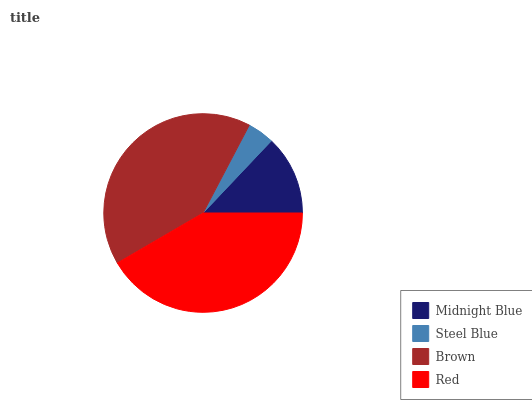Is Steel Blue the minimum?
Answer yes or no. Yes. Is Red the maximum?
Answer yes or no. Yes. Is Brown the minimum?
Answer yes or no. No. Is Brown the maximum?
Answer yes or no. No. Is Brown greater than Steel Blue?
Answer yes or no. Yes. Is Steel Blue less than Brown?
Answer yes or no. Yes. Is Steel Blue greater than Brown?
Answer yes or no. No. Is Brown less than Steel Blue?
Answer yes or no. No. Is Brown the high median?
Answer yes or no. Yes. Is Midnight Blue the low median?
Answer yes or no. Yes. Is Midnight Blue the high median?
Answer yes or no. No. Is Red the low median?
Answer yes or no. No. 